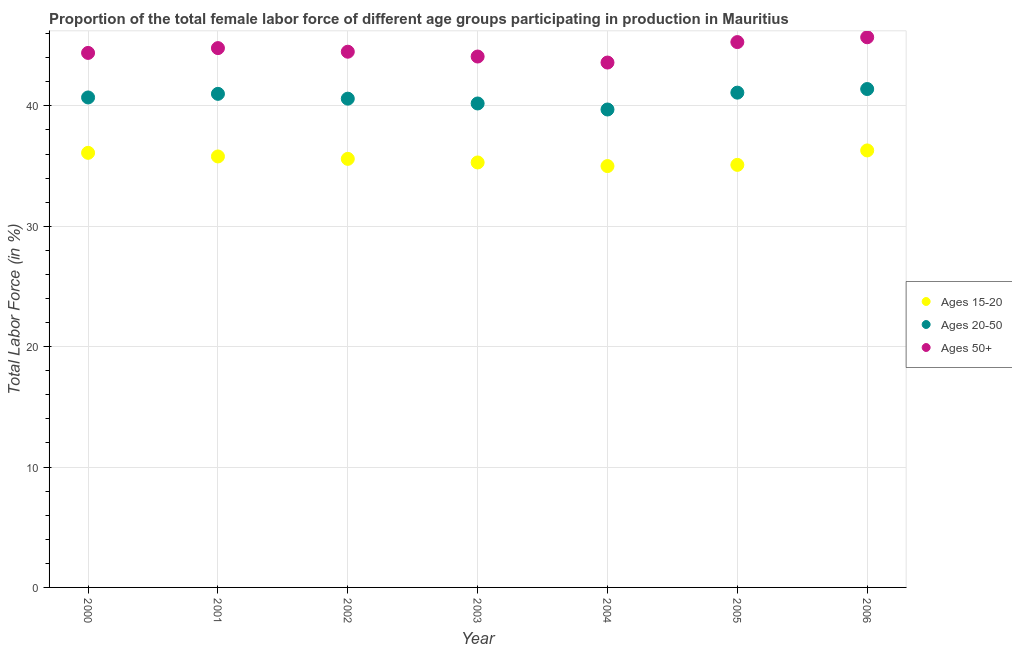What is the percentage of female labor force within the age group 15-20 in 2001?
Your response must be concise. 35.8. Across all years, what is the maximum percentage of female labor force within the age group 20-50?
Your answer should be very brief. 41.4. Across all years, what is the minimum percentage of female labor force within the age group 15-20?
Offer a terse response. 35. In which year was the percentage of female labor force above age 50 maximum?
Make the answer very short. 2006. What is the total percentage of female labor force within the age group 20-50 in the graph?
Provide a succinct answer. 284.7. What is the difference between the percentage of female labor force above age 50 in 2000 and that in 2004?
Ensure brevity in your answer.  0.8. What is the difference between the percentage of female labor force above age 50 in 2003 and the percentage of female labor force within the age group 20-50 in 2002?
Provide a succinct answer. 3.5. What is the average percentage of female labor force within the age group 20-50 per year?
Offer a terse response. 40.67. In the year 2001, what is the difference between the percentage of female labor force within the age group 15-20 and percentage of female labor force within the age group 20-50?
Offer a very short reply. -5.2. In how many years, is the percentage of female labor force within the age group 15-20 greater than 38 %?
Your answer should be compact. 0. What is the ratio of the percentage of female labor force within the age group 20-50 in 2003 to that in 2006?
Offer a terse response. 0.97. What is the difference between the highest and the second highest percentage of female labor force within the age group 20-50?
Make the answer very short. 0.3. What is the difference between the highest and the lowest percentage of female labor force within the age group 15-20?
Provide a succinct answer. 1.3. In how many years, is the percentage of female labor force above age 50 greater than the average percentage of female labor force above age 50 taken over all years?
Give a very brief answer. 3. Is the sum of the percentage of female labor force within the age group 15-20 in 2000 and 2006 greater than the maximum percentage of female labor force within the age group 20-50 across all years?
Provide a succinct answer. Yes. Is the percentage of female labor force above age 50 strictly less than the percentage of female labor force within the age group 15-20 over the years?
Keep it short and to the point. No. How many dotlines are there?
Provide a succinct answer. 3. What is the difference between two consecutive major ticks on the Y-axis?
Provide a short and direct response. 10. Are the values on the major ticks of Y-axis written in scientific E-notation?
Keep it short and to the point. No. Where does the legend appear in the graph?
Provide a short and direct response. Center right. How many legend labels are there?
Offer a terse response. 3. How are the legend labels stacked?
Give a very brief answer. Vertical. What is the title of the graph?
Your answer should be very brief. Proportion of the total female labor force of different age groups participating in production in Mauritius. Does "Coal" appear as one of the legend labels in the graph?
Keep it short and to the point. No. What is the Total Labor Force (in %) of Ages 15-20 in 2000?
Offer a terse response. 36.1. What is the Total Labor Force (in %) in Ages 20-50 in 2000?
Your answer should be compact. 40.7. What is the Total Labor Force (in %) in Ages 50+ in 2000?
Keep it short and to the point. 44.4. What is the Total Labor Force (in %) in Ages 15-20 in 2001?
Your response must be concise. 35.8. What is the Total Labor Force (in %) in Ages 20-50 in 2001?
Offer a terse response. 41. What is the Total Labor Force (in %) in Ages 50+ in 2001?
Provide a succinct answer. 44.8. What is the Total Labor Force (in %) in Ages 15-20 in 2002?
Offer a terse response. 35.6. What is the Total Labor Force (in %) in Ages 20-50 in 2002?
Provide a succinct answer. 40.6. What is the Total Labor Force (in %) in Ages 50+ in 2002?
Your response must be concise. 44.5. What is the Total Labor Force (in %) in Ages 15-20 in 2003?
Your answer should be very brief. 35.3. What is the Total Labor Force (in %) in Ages 20-50 in 2003?
Make the answer very short. 40.2. What is the Total Labor Force (in %) of Ages 50+ in 2003?
Make the answer very short. 44.1. What is the Total Labor Force (in %) of Ages 15-20 in 2004?
Offer a very short reply. 35. What is the Total Labor Force (in %) in Ages 20-50 in 2004?
Provide a succinct answer. 39.7. What is the Total Labor Force (in %) in Ages 50+ in 2004?
Give a very brief answer. 43.6. What is the Total Labor Force (in %) of Ages 15-20 in 2005?
Ensure brevity in your answer.  35.1. What is the Total Labor Force (in %) in Ages 20-50 in 2005?
Offer a terse response. 41.1. What is the Total Labor Force (in %) of Ages 50+ in 2005?
Keep it short and to the point. 45.3. What is the Total Labor Force (in %) of Ages 15-20 in 2006?
Make the answer very short. 36.3. What is the Total Labor Force (in %) in Ages 20-50 in 2006?
Make the answer very short. 41.4. What is the Total Labor Force (in %) in Ages 50+ in 2006?
Your answer should be very brief. 45.7. Across all years, what is the maximum Total Labor Force (in %) of Ages 15-20?
Your answer should be very brief. 36.3. Across all years, what is the maximum Total Labor Force (in %) in Ages 20-50?
Provide a short and direct response. 41.4. Across all years, what is the maximum Total Labor Force (in %) in Ages 50+?
Your answer should be compact. 45.7. Across all years, what is the minimum Total Labor Force (in %) in Ages 20-50?
Ensure brevity in your answer.  39.7. Across all years, what is the minimum Total Labor Force (in %) in Ages 50+?
Your answer should be very brief. 43.6. What is the total Total Labor Force (in %) of Ages 15-20 in the graph?
Provide a succinct answer. 249.2. What is the total Total Labor Force (in %) of Ages 20-50 in the graph?
Your response must be concise. 284.7. What is the total Total Labor Force (in %) of Ages 50+ in the graph?
Give a very brief answer. 312.4. What is the difference between the Total Labor Force (in %) in Ages 15-20 in 2000 and that in 2002?
Provide a short and direct response. 0.5. What is the difference between the Total Labor Force (in %) in Ages 50+ in 2000 and that in 2002?
Make the answer very short. -0.1. What is the difference between the Total Labor Force (in %) in Ages 15-20 in 2000 and that in 2003?
Make the answer very short. 0.8. What is the difference between the Total Labor Force (in %) of Ages 20-50 in 2000 and that in 2003?
Your answer should be compact. 0.5. What is the difference between the Total Labor Force (in %) of Ages 50+ in 2000 and that in 2003?
Your answer should be very brief. 0.3. What is the difference between the Total Labor Force (in %) in Ages 15-20 in 2000 and that in 2004?
Give a very brief answer. 1.1. What is the difference between the Total Labor Force (in %) of Ages 50+ in 2000 and that in 2004?
Your response must be concise. 0.8. What is the difference between the Total Labor Force (in %) in Ages 20-50 in 2000 and that in 2006?
Make the answer very short. -0.7. What is the difference between the Total Labor Force (in %) in Ages 15-20 in 2001 and that in 2002?
Ensure brevity in your answer.  0.2. What is the difference between the Total Labor Force (in %) of Ages 20-50 in 2001 and that in 2002?
Offer a very short reply. 0.4. What is the difference between the Total Labor Force (in %) of Ages 50+ in 2001 and that in 2002?
Give a very brief answer. 0.3. What is the difference between the Total Labor Force (in %) in Ages 15-20 in 2001 and that in 2003?
Provide a succinct answer. 0.5. What is the difference between the Total Labor Force (in %) in Ages 20-50 in 2001 and that in 2004?
Give a very brief answer. 1.3. What is the difference between the Total Labor Force (in %) in Ages 15-20 in 2002 and that in 2003?
Provide a short and direct response. 0.3. What is the difference between the Total Labor Force (in %) of Ages 15-20 in 2002 and that in 2004?
Your answer should be compact. 0.6. What is the difference between the Total Labor Force (in %) of Ages 15-20 in 2002 and that in 2005?
Provide a succinct answer. 0.5. What is the difference between the Total Labor Force (in %) of Ages 20-50 in 2002 and that in 2006?
Offer a terse response. -0.8. What is the difference between the Total Labor Force (in %) in Ages 50+ in 2002 and that in 2006?
Your answer should be very brief. -1.2. What is the difference between the Total Labor Force (in %) in Ages 15-20 in 2003 and that in 2004?
Ensure brevity in your answer.  0.3. What is the difference between the Total Labor Force (in %) in Ages 50+ in 2003 and that in 2004?
Ensure brevity in your answer.  0.5. What is the difference between the Total Labor Force (in %) of Ages 20-50 in 2003 and that in 2005?
Give a very brief answer. -0.9. What is the difference between the Total Labor Force (in %) of Ages 15-20 in 2003 and that in 2006?
Your response must be concise. -1. What is the difference between the Total Labor Force (in %) in Ages 20-50 in 2003 and that in 2006?
Your answer should be compact. -1.2. What is the difference between the Total Labor Force (in %) in Ages 20-50 in 2004 and that in 2005?
Your response must be concise. -1.4. What is the difference between the Total Labor Force (in %) of Ages 50+ in 2004 and that in 2006?
Offer a very short reply. -2.1. What is the difference between the Total Labor Force (in %) in Ages 20-50 in 2000 and the Total Labor Force (in %) in Ages 50+ in 2001?
Give a very brief answer. -4.1. What is the difference between the Total Labor Force (in %) in Ages 20-50 in 2000 and the Total Labor Force (in %) in Ages 50+ in 2003?
Offer a terse response. -3.4. What is the difference between the Total Labor Force (in %) of Ages 15-20 in 2000 and the Total Labor Force (in %) of Ages 20-50 in 2004?
Ensure brevity in your answer.  -3.6. What is the difference between the Total Labor Force (in %) in Ages 15-20 in 2000 and the Total Labor Force (in %) in Ages 50+ in 2004?
Provide a succinct answer. -7.5. What is the difference between the Total Labor Force (in %) of Ages 20-50 in 2000 and the Total Labor Force (in %) of Ages 50+ in 2004?
Offer a terse response. -2.9. What is the difference between the Total Labor Force (in %) of Ages 15-20 in 2000 and the Total Labor Force (in %) of Ages 50+ in 2005?
Provide a succinct answer. -9.2. What is the difference between the Total Labor Force (in %) of Ages 20-50 in 2000 and the Total Labor Force (in %) of Ages 50+ in 2006?
Offer a terse response. -5. What is the difference between the Total Labor Force (in %) of Ages 15-20 in 2001 and the Total Labor Force (in %) of Ages 20-50 in 2002?
Keep it short and to the point. -4.8. What is the difference between the Total Labor Force (in %) of Ages 15-20 in 2001 and the Total Labor Force (in %) of Ages 50+ in 2002?
Your response must be concise. -8.7. What is the difference between the Total Labor Force (in %) in Ages 20-50 in 2001 and the Total Labor Force (in %) in Ages 50+ in 2002?
Provide a succinct answer. -3.5. What is the difference between the Total Labor Force (in %) in Ages 15-20 in 2001 and the Total Labor Force (in %) in Ages 20-50 in 2003?
Your answer should be compact. -4.4. What is the difference between the Total Labor Force (in %) of Ages 15-20 in 2001 and the Total Labor Force (in %) of Ages 50+ in 2003?
Your answer should be compact. -8.3. What is the difference between the Total Labor Force (in %) of Ages 15-20 in 2001 and the Total Labor Force (in %) of Ages 50+ in 2004?
Keep it short and to the point. -7.8. What is the difference between the Total Labor Force (in %) of Ages 15-20 in 2001 and the Total Labor Force (in %) of Ages 50+ in 2006?
Your answer should be compact. -9.9. What is the difference between the Total Labor Force (in %) in Ages 20-50 in 2001 and the Total Labor Force (in %) in Ages 50+ in 2006?
Your answer should be very brief. -4.7. What is the difference between the Total Labor Force (in %) of Ages 15-20 in 2002 and the Total Labor Force (in %) of Ages 50+ in 2003?
Provide a short and direct response. -8.5. What is the difference between the Total Labor Force (in %) of Ages 20-50 in 2002 and the Total Labor Force (in %) of Ages 50+ in 2003?
Give a very brief answer. -3.5. What is the difference between the Total Labor Force (in %) of Ages 15-20 in 2002 and the Total Labor Force (in %) of Ages 20-50 in 2004?
Make the answer very short. -4.1. What is the difference between the Total Labor Force (in %) of Ages 15-20 in 2002 and the Total Labor Force (in %) of Ages 50+ in 2004?
Provide a short and direct response. -8. What is the difference between the Total Labor Force (in %) of Ages 20-50 in 2002 and the Total Labor Force (in %) of Ages 50+ in 2004?
Offer a very short reply. -3. What is the difference between the Total Labor Force (in %) in Ages 15-20 in 2002 and the Total Labor Force (in %) in Ages 50+ in 2005?
Provide a short and direct response. -9.7. What is the difference between the Total Labor Force (in %) of Ages 20-50 in 2002 and the Total Labor Force (in %) of Ages 50+ in 2005?
Your answer should be compact. -4.7. What is the difference between the Total Labor Force (in %) in Ages 20-50 in 2002 and the Total Labor Force (in %) in Ages 50+ in 2006?
Offer a very short reply. -5.1. What is the difference between the Total Labor Force (in %) in Ages 20-50 in 2003 and the Total Labor Force (in %) in Ages 50+ in 2004?
Provide a short and direct response. -3.4. What is the difference between the Total Labor Force (in %) in Ages 20-50 in 2003 and the Total Labor Force (in %) in Ages 50+ in 2005?
Provide a succinct answer. -5.1. What is the difference between the Total Labor Force (in %) in Ages 15-20 in 2003 and the Total Labor Force (in %) in Ages 20-50 in 2006?
Your answer should be compact. -6.1. What is the difference between the Total Labor Force (in %) in Ages 15-20 in 2004 and the Total Labor Force (in %) in Ages 20-50 in 2005?
Offer a terse response. -6.1. What is the difference between the Total Labor Force (in %) of Ages 15-20 in 2004 and the Total Labor Force (in %) of Ages 50+ in 2005?
Your answer should be very brief. -10.3. What is the difference between the Total Labor Force (in %) in Ages 15-20 in 2004 and the Total Labor Force (in %) in Ages 20-50 in 2006?
Provide a short and direct response. -6.4. What is the difference between the Total Labor Force (in %) of Ages 15-20 in 2005 and the Total Labor Force (in %) of Ages 50+ in 2006?
Make the answer very short. -10.6. What is the average Total Labor Force (in %) in Ages 15-20 per year?
Provide a succinct answer. 35.6. What is the average Total Labor Force (in %) of Ages 20-50 per year?
Ensure brevity in your answer.  40.67. What is the average Total Labor Force (in %) in Ages 50+ per year?
Make the answer very short. 44.63. In the year 2000, what is the difference between the Total Labor Force (in %) in Ages 15-20 and Total Labor Force (in %) in Ages 50+?
Your answer should be very brief. -8.3. What is the ratio of the Total Labor Force (in %) of Ages 15-20 in 2000 to that in 2001?
Offer a terse response. 1.01. What is the ratio of the Total Labor Force (in %) in Ages 20-50 in 2000 to that in 2002?
Ensure brevity in your answer.  1. What is the ratio of the Total Labor Force (in %) of Ages 15-20 in 2000 to that in 2003?
Offer a terse response. 1.02. What is the ratio of the Total Labor Force (in %) in Ages 20-50 in 2000 to that in 2003?
Ensure brevity in your answer.  1.01. What is the ratio of the Total Labor Force (in %) of Ages 50+ in 2000 to that in 2003?
Your answer should be compact. 1.01. What is the ratio of the Total Labor Force (in %) in Ages 15-20 in 2000 to that in 2004?
Make the answer very short. 1.03. What is the ratio of the Total Labor Force (in %) in Ages 20-50 in 2000 to that in 2004?
Provide a short and direct response. 1.03. What is the ratio of the Total Labor Force (in %) in Ages 50+ in 2000 to that in 2004?
Provide a succinct answer. 1.02. What is the ratio of the Total Labor Force (in %) of Ages 15-20 in 2000 to that in 2005?
Your response must be concise. 1.03. What is the ratio of the Total Labor Force (in %) in Ages 20-50 in 2000 to that in 2005?
Make the answer very short. 0.99. What is the ratio of the Total Labor Force (in %) of Ages 50+ in 2000 to that in 2005?
Keep it short and to the point. 0.98. What is the ratio of the Total Labor Force (in %) in Ages 15-20 in 2000 to that in 2006?
Make the answer very short. 0.99. What is the ratio of the Total Labor Force (in %) of Ages 20-50 in 2000 to that in 2006?
Your answer should be compact. 0.98. What is the ratio of the Total Labor Force (in %) of Ages 50+ in 2000 to that in 2006?
Your answer should be very brief. 0.97. What is the ratio of the Total Labor Force (in %) of Ages 15-20 in 2001 to that in 2002?
Your answer should be very brief. 1.01. What is the ratio of the Total Labor Force (in %) in Ages 20-50 in 2001 to that in 2002?
Offer a very short reply. 1.01. What is the ratio of the Total Labor Force (in %) in Ages 50+ in 2001 to that in 2002?
Make the answer very short. 1.01. What is the ratio of the Total Labor Force (in %) of Ages 15-20 in 2001 to that in 2003?
Provide a succinct answer. 1.01. What is the ratio of the Total Labor Force (in %) in Ages 20-50 in 2001 to that in 2003?
Keep it short and to the point. 1.02. What is the ratio of the Total Labor Force (in %) in Ages 50+ in 2001 to that in 2003?
Your answer should be very brief. 1.02. What is the ratio of the Total Labor Force (in %) of Ages 15-20 in 2001 to that in 2004?
Ensure brevity in your answer.  1.02. What is the ratio of the Total Labor Force (in %) of Ages 20-50 in 2001 to that in 2004?
Offer a very short reply. 1.03. What is the ratio of the Total Labor Force (in %) in Ages 50+ in 2001 to that in 2004?
Make the answer very short. 1.03. What is the ratio of the Total Labor Force (in %) in Ages 15-20 in 2001 to that in 2005?
Give a very brief answer. 1.02. What is the ratio of the Total Labor Force (in %) in Ages 20-50 in 2001 to that in 2005?
Give a very brief answer. 1. What is the ratio of the Total Labor Force (in %) of Ages 15-20 in 2001 to that in 2006?
Your answer should be compact. 0.99. What is the ratio of the Total Labor Force (in %) of Ages 20-50 in 2001 to that in 2006?
Ensure brevity in your answer.  0.99. What is the ratio of the Total Labor Force (in %) in Ages 50+ in 2001 to that in 2006?
Your answer should be very brief. 0.98. What is the ratio of the Total Labor Force (in %) in Ages 15-20 in 2002 to that in 2003?
Your response must be concise. 1.01. What is the ratio of the Total Labor Force (in %) of Ages 20-50 in 2002 to that in 2003?
Offer a terse response. 1.01. What is the ratio of the Total Labor Force (in %) in Ages 50+ in 2002 to that in 2003?
Offer a terse response. 1.01. What is the ratio of the Total Labor Force (in %) of Ages 15-20 in 2002 to that in 2004?
Keep it short and to the point. 1.02. What is the ratio of the Total Labor Force (in %) of Ages 20-50 in 2002 to that in 2004?
Your answer should be compact. 1.02. What is the ratio of the Total Labor Force (in %) of Ages 50+ in 2002 to that in 2004?
Make the answer very short. 1.02. What is the ratio of the Total Labor Force (in %) of Ages 15-20 in 2002 to that in 2005?
Offer a very short reply. 1.01. What is the ratio of the Total Labor Force (in %) of Ages 50+ in 2002 to that in 2005?
Offer a terse response. 0.98. What is the ratio of the Total Labor Force (in %) of Ages 15-20 in 2002 to that in 2006?
Keep it short and to the point. 0.98. What is the ratio of the Total Labor Force (in %) in Ages 20-50 in 2002 to that in 2006?
Provide a short and direct response. 0.98. What is the ratio of the Total Labor Force (in %) of Ages 50+ in 2002 to that in 2006?
Offer a terse response. 0.97. What is the ratio of the Total Labor Force (in %) in Ages 15-20 in 2003 to that in 2004?
Your response must be concise. 1.01. What is the ratio of the Total Labor Force (in %) in Ages 20-50 in 2003 to that in 2004?
Keep it short and to the point. 1.01. What is the ratio of the Total Labor Force (in %) in Ages 50+ in 2003 to that in 2004?
Give a very brief answer. 1.01. What is the ratio of the Total Labor Force (in %) of Ages 20-50 in 2003 to that in 2005?
Keep it short and to the point. 0.98. What is the ratio of the Total Labor Force (in %) of Ages 50+ in 2003 to that in 2005?
Give a very brief answer. 0.97. What is the ratio of the Total Labor Force (in %) in Ages 15-20 in 2003 to that in 2006?
Offer a very short reply. 0.97. What is the ratio of the Total Labor Force (in %) of Ages 50+ in 2003 to that in 2006?
Offer a terse response. 0.96. What is the ratio of the Total Labor Force (in %) in Ages 15-20 in 2004 to that in 2005?
Make the answer very short. 1. What is the ratio of the Total Labor Force (in %) of Ages 20-50 in 2004 to that in 2005?
Provide a succinct answer. 0.97. What is the ratio of the Total Labor Force (in %) of Ages 50+ in 2004 to that in 2005?
Keep it short and to the point. 0.96. What is the ratio of the Total Labor Force (in %) in Ages 15-20 in 2004 to that in 2006?
Keep it short and to the point. 0.96. What is the ratio of the Total Labor Force (in %) in Ages 20-50 in 2004 to that in 2006?
Give a very brief answer. 0.96. What is the ratio of the Total Labor Force (in %) of Ages 50+ in 2004 to that in 2006?
Provide a succinct answer. 0.95. What is the ratio of the Total Labor Force (in %) in Ages 15-20 in 2005 to that in 2006?
Your response must be concise. 0.97. What is the ratio of the Total Labor Force (in %) in Ages 20-50 in 2005 to that in 2006?
Provide a short and direct response. 0.99. What is the ratio of the Total Labor Force (in %) of Ages 50+ in 2005 to that in 2006?
Provide a succinct answer. 0.99. What is the difference between the highest and the second highest Total Labor Force (in %) in Ages 15-20?
Your response must be concise. 0.2. What is the difference between the highest and the second highest Total Labor Force (in %) of Ages 50+?
Your answer should be compact. 0.4. What is the difference between the highest and the lowest Total Labor Force (in %) of Ages 20-50?
Ensure brevity in your answer.  1.7. What is the difference between the highest and the lowest Total Labor Force (in %) of Ages 50+?
Your response must be concise. 2.1. 